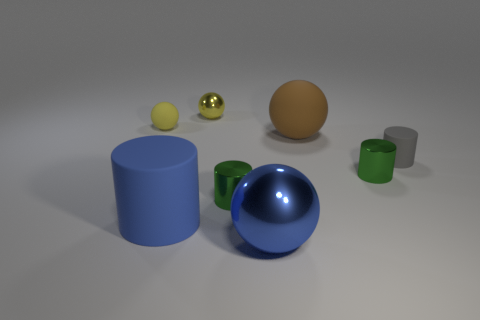Subtract all brown balls. Subtract all cyan cylinders. How many balls are left? 3 Add 1 big blue matte things. How many objects exist? 9 Add 3 small gray matte cylinders. How many small gray matte cylinders exist? 4 Subtract 0 green spheres. How many objects are left? 8 Subtract all cyan objects. Subtract all green objects. How many objects are left? 6 Add 7 small yellow shiny objects. How many small yellow shiny objects are left? 8 